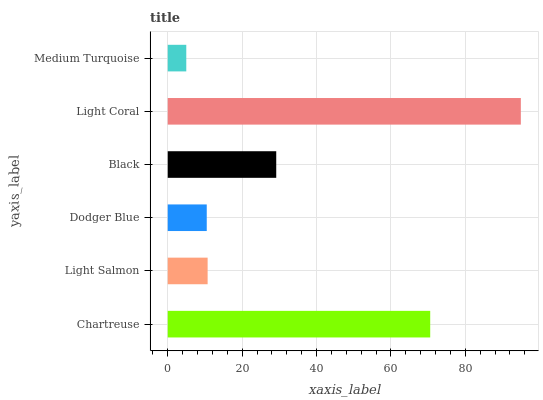Is Medium Turquoise the minimum?
Answer yes or no. Yes. Is Light Coral the maximum?
Answer yes or no. Yes. Is Light Salmon the minimum?
Answer yes or no. No. Is Light Salmon the maximum?
Answer yes or no. No. Is Chartreuse greater than Light Salmon?
Answer yes or no. Yes. Is Light Salmon less than Chartreuse?
Answer yes or no. Yes. Is Light Salmon greater than Chartreuse?
Answer yes or no. No. Is Chartreuse less than Light Salmon?
Answer yes or no. No. Is Black the high median?
Answer yes or no. Yes. Is Light Salmon the low median?
Answer yes or no. Yes. Is Light Coral the high median?
Answer yes or no. No. Is Dodger Blue the low median?
Answer yes or no. No. 